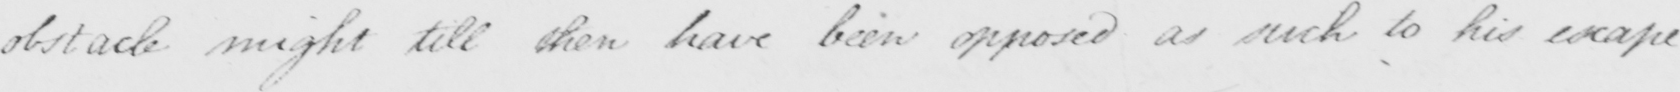Please transcribe the handwritten text in this image. obstacle might till then have been opposed as such to his escape. 